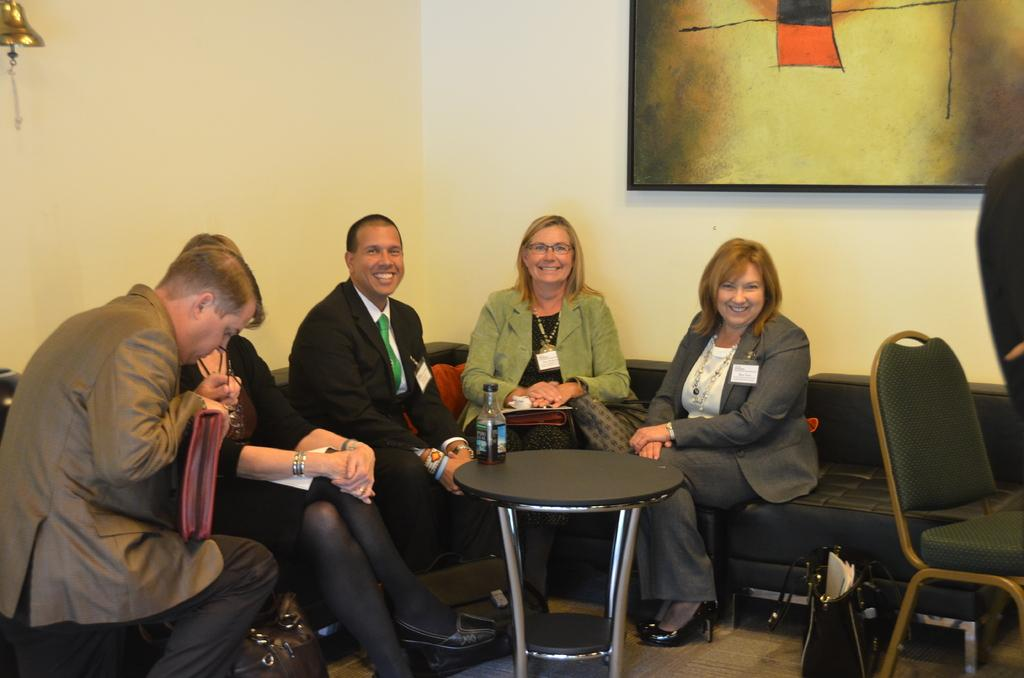How many people are in the image? There are five people in the image. What are the people doing in the image? The people are sitting on a sofa. What is in front of the sofa? There is a table in front of the sofa. What is on the table? There is a bottle on the table. What can be seen on the wall behind the people? There is a frame on the wall behind the people. What type of hair is visible on the side of the sofa in the image? There is no hair visible on the side of the sofa in the image. What kind of competition is taking place in the image? There is no competition present in the image; it features five people sitting on a sofa. 